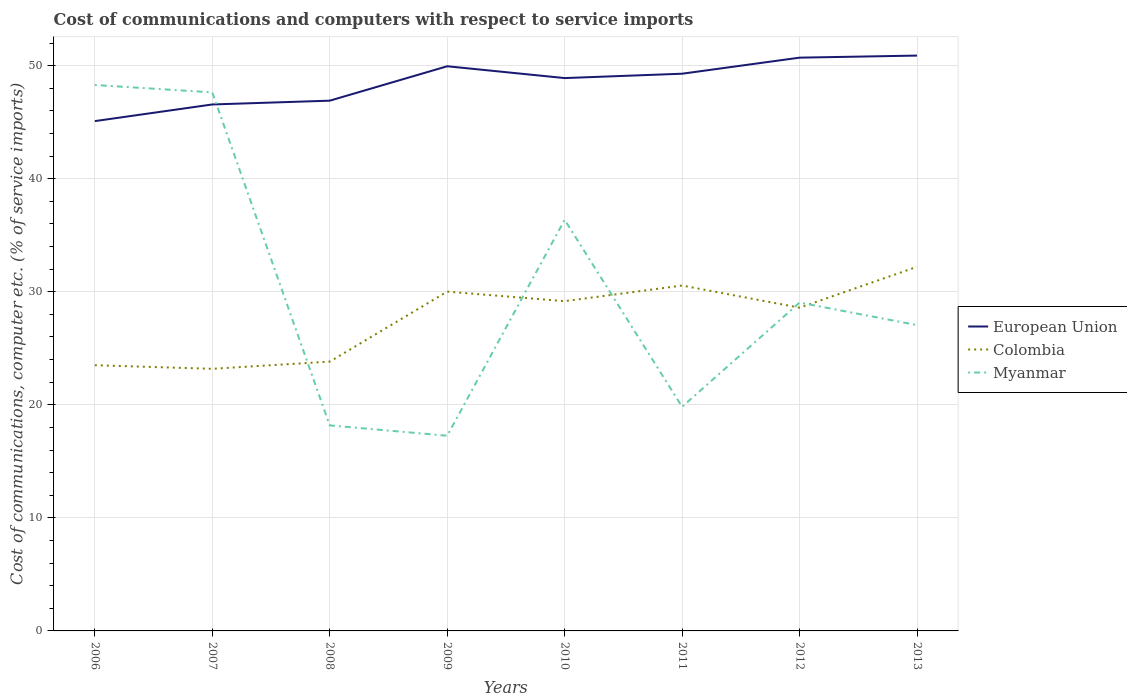How many different coloured lines are there?
Provide a succinct answer. 3. Does the line corresponding to European Union intersect with the line corresponding to Colombia?
Provide a succinct answer. No. Across all years, what is the maximum cost of communications and computers in European Union?
Your answer should be very brief. 45.09. What is the total cost of communications and computers in Colombia in the graph?
Provide a short and direct response. -5.09. What is the difference between the highest and the second highest cost of communications and computers in Colombia?
Offer a terse response. 9.02. What is the difference between the highest and the lowest cost of communications and computers in Colombia?
Keep it short and to the point. 5. Are the values on the major ticks of Y-axis written in scientific E-notation?
Your response must be concise. No. Does the graph contain grids?
Ensure brevity in your answer.  Yes. Where does the legend appear in the graph?
Provide a succinct answer. Center right. How are the legend labels stacked?
Provide a succinct answer. Vertical. What is the title of the graph?
Offer a very short reply. Cost of communications and computers with respect to service imports. What is the label or title of the Y-axis?
Make the answer very short. Cost of communications, computer etc. (% of service imports). What is the Cost of communications, computer etc. (% of service imports) of European Union in 2006?
Your answer should be very brief. 45.09. What is the Cost of communications, computer etc. (% of service imports) in Colombia in 2006?
Your answer should be compact. 23.5. What is the Cost of communications, computer etc. (% of service imports) in Myanmar in 2006?
Your answer should be very brief. 48.29. What is the Cost of communications, computer etc. (% of service imports) of European Union in 2007?
Your answer should be very brief. 46.57. What is the Cost of communications, computer etc. (% of service imports) of Colombia in 2007?
Provide a succinct answer. 23.18. What is the Cost of communications, computer etc. (% of service imports) in Myanmar in 2007?
Your response must be concise. 47.64. What is the Cost of communications, computer etc. (% of service imports) in European Union in 2008?
Your answer should be very brief. 46.9. What is the Cost of communications, computer etc. (% of service imports) of Colombia in 2008?
Your response must be concise. 23.82. What is the Cost of communications, computer etc. (% of service imports) of Myanmar in 2008?
Provide a succinct answer. 18.18. What is the Cost of communications, computer etc. (% of service imports) in European Union in 2009?
Your response must be concise. 49.95. What is the Cost of communications, computer etc. (% of service imports) in Colombia in 2009?
Your answer should be very brief. 30.01. What is the Cost of communications, computer etc. (% of service imports) of Myanmar in 2009?
Make the answer very short. 17.26. What is the Cost of communications, computer etc. (% of service imports) of European Union in 2010?
Offer a terse response. 48.9. What is the Cost of communications, computer etc. (% of service imports) of Colombia in 2010?
Keep it short and to the point. 29.17. What is the Cost of communications, computer etc. (% of service imports) in Myanmar in 2010?
Offer a very short reply. 36.37. What is the Cost of communications, computer etc. (% of service imports) in European Union in 2011?
Keep it short and to the point. 49.29. What is the Cost of communications, computer etc. (% of service imports) of Colombia in 2011?
Provide a short and direct response. 30.55. What is the Cost of communications, computer etc. (% of service imports) in Myanmar in 2011?
Make the answer very short. 19.82. What is the Cost of communications, computer etc. (% of service imports) in European Union in 2012?
Your answer should be compact. 50.71. What is the Cost of communications, computer etc. (% of service imports) of Colombia in 2012?
Offer a very short reply. 28.59. What is the Cost of communications, computer etc. (% of service imports) in Myanmar in 2012?
Give a very brief answer. 29.04. What is the Cost of communications, computer etc. (% of service imports) of European Union in 2013?
Your answer should be very brief. 50.89. What is the Cost of communications, computer etc. (% of service imports) in Colombia in 2013?
Provide a short and direct response. 32.21. What is the Cost of communications, computer etc. (% of service imports) of Myanmar in 2013?
Your answer should be compact. 27.05. Across all years, what is the maximum Cost of communications, computer etc. (% of service imports) in European Union?
Your response must be concise. 50.89. Across all years, what is the maximum Cost of communications, computer etc. (% of service imports) of Colombia?
Your response must be concise. 32.21. Across all years, what is the maximum Cost of communications, computer etc. (% of service imports) in Myanmar?
Keep it short and to the point. 48.29. Across all years, what is the minimum Cost of communications, computer etc. (% of service imports) in European Union?
Your response must be concise. 45.09. Across all years, what is the minimum Cost of communications, computer etc. (% of service imports) of Colombia?
Ensure brevity in your answer.  23.18. Across all years, what is the minimum Cost of communications, computer etc. (% of service imports) in Myanmar?
Your answer should be compact. 17.26. What is the total Cost of communications, computer etc. (% of service imports) of European Union in the graph?
Give a very brief answer. 388.29. What is the total Cost of communications, computer etc. (% of service imports) of Colombia in the graph?
Provide a short and direct response. 221.03. What is the total Cost of communications, computer etc. (% of service imports) of Myanmar in the graph?
Your answer should be very brief. 243.65. What is the difference between the Cost of communications, computer etc. (% of service imports) of European Union in 2006 and that in 2007?
Offer a terse response. -1.47. What is the difference between the Cost of communications, computer etc. (% of service imports) in Colombia in 2006 and that in 2007?
Offer a terse response. 0.32. What is the difference between the Cost of communications, computer etc. (% of service imports) in Myanmar in 2006 and that in 2007?
Ensure brevity in your answer.  0.65. What is the difference between the Cost of communications, computer etc. (% of service imports) of European Union in 2006 and that in 2008?
Give a very brief answer. -1.81. What is the difference between the Cost of communications, computer etc. (% of service imports) of Colombia in 2006 and that in 2008?
Offer a terse response. -0.32. What is the difference between the Cost of communications, computer etc. (% of service imports) of Myanmar in 2006 and that in 2008?
Make the answer very short. 30.11. What is the difference between the Cost of communications, computer etc. (% of service imports) in European Union in 2006 and that in 2009?
Ensure brevity in your answer.  -4.85. What is the difference between the Cost of communications, computer etc. (% of service imports) in Colombia in 2006 and that in 2009?
Make the answer very short. -6.51. What is the difference between the Cost of communications, computer etc. (% of service imports) of Myanmar in 2006 and that in 2009?
Keep it short and to the point. 31.02. What is the difference between the Cost of communications, computer etc. (% of service imports) of European Union in 2006 and that in 2010?
Make the answer very short. -3.81. What is the difference between the Cost of communications, computer etc. (% of service imports) in Colombia in 2006 and that in 2010?
Make the answer very short. -5.67. What is the difference between the Cost of communications, computer etc. (% of service imports) of Myanmar in 2006 and that in 2010?
Give a very brief answer. 11.92. What is the difference between the Cost of communications, computer etc. (% of service imports) of European Union in 2006 and that in 2011?
Give a very brief answer. -4.19. What is the difference between the Cost of communications, computer etc. (% of service imports) of Colombia in 2006 and that in 2011?
Offer a very short reply. -7.05. What is the difference between the Cost of communications, computer etc. (% of service imports) of Myanmar in 2006 and that in 2011?
Your answer should be very brief. 28.46. What is the difference between the Cost of communications, computer etc. (% of service imports) of European Union in 2006 and that in 2012?
Offer a terse response. -5.61. What is the difference between the Cost of communications, computer etc. (% of service imports) in Colombia in 2006 and that in 2012?
Your answer should be compact. -5.09. What is the difference between the Cost of communications, computer etc. (% of service imports) in Myanmar in 2006 and that in 2012?
Offer a terse response. 19.24. What is the difference between the Cost of communications, computer etc. (% of service imports) in European Union in 2006 and that in 2013?
Offer a very short reply. -5.8. What is the difference between the Cost of communications, computer etc. (% of service imports) of Colombia in 2006 and that in 2013?
Ensure brevity in your answer.  -8.71. What is the difference between the Cost of communications, computer etc. (% of service imports) of Myanmar in 2006 and that in 2013?
Your answer should be compact. 21.24. What is the difference between the Cost of communications, computer etc. (% of service imports) of European Union in 2007 and that in 2008?
Your answer should be compact. -0.33. What is the difference between the Cost of communications, computer etc. (% of service imports) in Colombia in 2007 and that in 2008?
Your answer should be very brief. -0.64. What is the difference between the Cost of communications, computer etc. (% of service imports) in Myanmar in 2007 and that in 2008?
Offer a terse response. 29.46. What is the difference between the Cost of communications, computer etc. (% of service imports) in European Union in 2007 and that in 2009?
Your answer should be compact. -3.38. What is the difference between the Cost of communications, computer etc. (% of service imports) of Colombia in 2007 and that in 2009?
Provide a short and direct response. -6.83. What is the difference between the Cost of communications, computer etc. (% of service imports) of Myanmar in 2007 and that in 2009?
Keep it short and to the point. 30.37. What is the difference between the Cost of communications, computer etc. (% of service imports) of European Union in 2007 and that in 2010?
Provide a succinct answer. -2.33. What is the difference between the Cost of communications, computer etc. (% of service imports) of Colombia in 2007 and that in 2010?
Offer a very short reply. -5.98. What is the difference between the Cost of communications, computer etc. (% of service imports) in Myanmar in 2007 and that in 2010?
Your response must be concise. 11.27. What is the difference between the Cost of communications, computer etc. (% of service imports) of European Union in 2007 and that in 2011?
Offer a terse response. -2.72. What is the difference between the Cost of communications, computer etc. (% of service imports) of Colombia in 2007 and that in 2011?
Make the answer very short. -7.37. What is the difference between the Cost of communications, computer etc. (% of service imports) of Myanmar in 2007 and that in 2011?
Offer a terse response. 27.81. What is the difference between the Cost of communications, computer etc. (% of service imports) of European Union in 2007 and that in 2012?
Ensure brevity in your answer.  -4.14. What is the difference between the Cost of communications, computer etc. (% of service imports) in Colombia in 2007 and that in 2012?
Offer a very short reply. -5.41. What is the difference between the Cost of communications, computer etc. (% of service imports) of Myanmar in 2007 and that in 2012?
Your answer should be compact. 18.59. What is the difference between the Cost of communications, computer etc. (% of service imports) of European Union in 2007 and that in 2013?
Give a very brief answer. -4.32. What is the difference between the Cost of communications, computer etc. (% of service imports) in Colombia in 2007 and that in 2013?
Provide a short and direct response. -9.02. What is the difference between the Cost of communications, computer etc. (% of service imports) of Myanmar in 2007 and that in 2013?
Provide a succinct answer. 20.59. What is the difference between the Cost of communications, computer etc. (% of service imports) in European Union in 2008 and that in 2009?
Provide a short and direct response. -3.04. What is the difference between the Cost of communications, computer etc. (% of service imports) in Colombia in 2008 and that in 2009?
Your answer should be compact. -6.19. What is the difference between the Cost of communications, computer etc. (% of service imports) in Myanmar in 2008 and that in 2009?
Provide a short and direct response. 0.92. What is the difference between the Cost of communications, computer etc. (% of service imports) of European Union in 2008 and that in 2010?
Make the answer very short. -2. What is the difference between the Cost of communications, computer etc. (% of service imports) in Colombia in 2008 and that in 2010?
Your answer should be compact. -5.35. What is the difference between the Cost of communications, computer etc. (% of service imports) in Myanmar in 2008 and that in 2010?
Offer a very short reply. -18.19. What is the difference between the Cost of communications, computer etc. (% of service imports) of European Union in 2008 and that in 2011?
Your answer should be compact. -2.39. What is the difference between the Cost of communications, computer etc. (% of service imports) in Colombia in 2008 and that in 2011?
Make the answer very short. -6.73. What is the difference between the Cost of communications, computer etc. (% of service imports) of Myanmar in 2008 and that in 2011?
Offer a terse response. -1.65. What is the difference between the Cost of communications, computer etc. (% of service imports) in European Union in 2008 and that in 2012?
Make the answer very short. -3.81. What is the difference between the Cost of communications, computer etc. (% of service imports) in Colombia in 2008 and that in 2012?
Offer a terse response. -4.77. What is the difference between the Cost of communications, computer etc. (% of service imports) of Myanmar in 2008 and that in 2012?
Keep it short and to the point. -10.86. What is the difference between the Cost of communications, computer etc. (% of service imports) in European Union in 2008 and that in 2013?
Offer a very short reply. -3.99. What is the difference between the Cost of communications, computer etc. (% of service imports) of Colombia in 2008 and that in 2013?
Your answer should be compact. -8.38. What is the difference between the Cost of communications, computer etc. (% of service imports) of Myanmar in 2008 and that in 2013?
Make the answer very short. -8.87. What is the difference between the Cost of communications, computer etc. (% of service imports) in European Union in 2009 and that in 2010?
Offer a very short reply. 1.05. What is the difference between the Cost of communications, computer etc. (% of service imports) in Colombia in 2009 and that in 2010?
Provide a succinct answer. 0.84. What is the difference between the Cost of communications, computer etc. (% of service imports) of Myanmar in 2009 and that in 2010?
Give a very brief answer. -19.1. What is the difference between the Cost of communications, computer etc. (% of service imports) in European Union in 2009 and that in 2011?
Make the answer very short. 0.66. What is the difference between the Cost of communications, computer etc. (% of service imports) of Colombia in 2009 and that in 2011?
Your answer should be compact. -0.54. What is the difference between the Cost of communications, computer etc. (% of service imports) of Myanmar in 2009 and that in 2011?
Keep it short and to the point. -2.56. What is the difference between the Cost of communications, computer etc. (% of service imports) in European Union in 2009 and that in 2012?
Your response must be concise. -0.76. What is the difference between the Cost of communications, computer etc. (% of service imports) of Colombia in 2009 and that in 2012?
Your response must be concise. 1.42. What is the difference between the Cost of communications, computer etc. (% of service imports) of Myanmar in 2009 and that in 2012?
Ensure brevity in your answer.  -11.78. What is the difference between the Cost of communications, computer etc. (% of service imports) of European Union in 2009 and that in 2013?
Provide a succinct answer. -0.94. What is the difference between the Cost of communications, computer etc. (% of service imports) in Colombia in 2009 and that in 2013?
Give a very brief answer. -2.19. What is the difference between the Cost of communications, computer etc. (% of service imports) in Myanmar in 2009 and that in 2013?
Your answer should be compact. -9.79. What is the difference between the Cost of communications, computer etc. (% of service imports) in European Union in 2010 and that in 2011?
Offer a terse response. -0.39. What is the difference between the Cost of communications, computer etc. (% of service imports) in Colombia in 2010 and that in 2011?
Provide a short and direct response. -1.38. What is the difference between the Cost of communications, computer etc. (% of service imports) of Myanmar in 2010 and that in 2011?
Offer a terse response. 16.54. What is the difference between the Cost of communications, computer etc. (% of service imports) in European Union in 2010 and that in 2012?
Ensure brevity in your answer.  -1.81. What is the difference between the Cost of communications, computer etc. (% of service imports) in Colombia in 2010 and that in 2012?
Your answer should be very brief. 0.58. What is the difference between the Cost of communications, computer etc. (% of service imports) in Myanmar in 2010 and that in 2012?
Your answer should be very brief. 7.32. What is the difference between the Cost of communications, computer etc. (% of service imports) in European Union in 2010 and that in 2013?
Your response must be concise. -1.99. What is the difference between the Cost of communications, computer etc. (% of service imports) in Colombia in 2010 and that in 2013?
Offer a terse response. -3.04. What is the difference between the Cost of communications, computer etc. (% of service imports) in Myanmar in 2010 and that in 2013?
Provide a short and direct response. 9.32. What is the difference between the Cost of communications, computer etc. (% of service imports) of European Union in 2011 and that in 2012?
Offer a terse response. -1.42. What is the difference between the Cost of communications, computer etc. (% of service imports) of Colombia in 2011 and that in 2012?
Make the answer very short. 1.96. What is the difference between the Cost of communications, computer etc. (% of service imports) in Myanmar in 2011 and that in 2012?
Your response must be concise. -9.22. What is the difference between the Cost of communications, computer etc. (% of service imports) in European Union in 2011 and that in 2013?
Provide a succinct answer. -1.6. What is the difference between the Cost of communications, computer etc. (% of service imports) in Colombia in 2011 and that in 2013?
Keep it short and to the point. -1.65. What is the difference between the Cost of communications, computer etc. (% of service imports) in Myanmar in 2011 and that in 2013?
Your answer should be compact. -7.22. What is the difference between the Cost of communications, computer etc. (% of service imports) in European Union in 2012 and that in 2013?
Offer a terse response. -0.18. What is the difference between the Cost of communications, computer etc. (% of service imports) in Colombia in 2012 and that in 2013?
Ensure brevity in your answer.  -3.62. What is the difference between the Cost of communications, computer etc. (% of service imports) in Myanmar in 2012 and that in 2013?
Make the answer very short. 1.99. What is the difference between the Cost of communications, computer etc. (% of service imports) of European Union in 2006 and the Cost of communications, computer etc. (% of service imports) of Colombia in 2007?
Provide a succinct answer. 21.91. What is the difference between the Cost of communications, computer etc. (% of service imports) of European Union in 2006 and the Cost of communications, computer etc. (% of service imports) of Myanmar in 2007?
Provide a short and direct response. -2.54. What is the difference between the Cost of communications, computer etc. (% of service imports) of Colombia in 2006 and the Cost of communications, computer etc. (% of service imports) of Myanmar in 2007?
Keep it short and to the point. -24.14. What is the difference between the Cost of communications, computer etc. (% of service imports) of European Union in 2006 and the Cost of communications, computer etc. (% of service imports) of Colombia in 2008?
Provide a short and direct response. 21.27. What is the difference between the Cost of communications, computer etc. (% of service imports) in European Union in 2006 and the Cost of communications, computer etc. (% of service imports) in Myanmar in 2008?
Your answer should be compact. 26.92. What is the difference between the Cost of communications, computer etc. (% of service imports) in Colombia in 2006 and the Cost of communications, computer etc. (% of service imports) in Myanmar in 2008?
Your answer should be very brief. 5.32. What is the difference between the Cost of communications, computer etc. (% of service imports) of European Union in 2006 and the Cost of communications, computer etc. (% of service imports) of Colombia in 2009?
Your answer should be compact. 15.08. What is the difference between the Cost of communications, computer etc. (% of service imports) in European Union in 2006 and the Cost of communications, computer etc. (% of service imports) in Myanmar in 2009?
Keep it short and to the point. 27.83. What is the difference between the Cost of communications, computer etc. (% of service imports) in Colombia in 2006 and the Cost of communications, computer etc. (% of service imports) in Myanmar in 2009?
Your answer should be very brief. 6.24. What is the difference between the Cost of communications, computer etc. (% of service imports) in European Union in 2006 and the Cost of communications, computer etc. (% of service imports) in Colombia in 2010?
Provide a short and direct response. 15.93. What is the difference between the Cost of communications, computer etc. (% of service imports) of European Union in 2006 and the Cost of communications, computer etc. (% of service imports) of Myanmar in 2010?
Give a very brief answer. 8.73. What is the difference between the Cost of communications, computer etc. (% of service imports) in Colombia in 2006 and the Cost of communications, computer etc. (% of service imports) in Myanmar in 2010?
Your answer should be compact. -12.87. What is the difference between the Cost of communications, computer etc. (% of service imports) of European Union in 2006 and the Cost of communications, computer etc. (% of service imports) of Colombia in 2011?
Provide a short and direct response. 14.54. What is the difference between the Cost of communications, computer etc. (% of service imports) in European Union in 2006 and the Cost of communications, computer etc. (% of service imports) in Myanmar in 2011?
Provide a short and direct response. 25.27. What is the difference between the Cost of communications, computer etc. (% of service imports) in Colombia in 2006 and the Cost of communications, computer etc. (% of service imports) in Myanmar in 2011?
Your answer should be compact. 3.68. What is the difference between the Cost of communications, computer etc. (% of service imports) in European Union in 2006 and the Cost of communications, computer etc. (% of service imports) in Colombia in 2012?
Your answer should be compact. 16.5. What is the difference between the Cost of communications, computer etc. (% of service imports) in European Union in 2006 and the Cost of communications, computer etc. (% of service imports) in Myanmar in 2012?
Your answer should be very brief. 16.05. What is the difference between the Cost of communications, computer etc. (% of service imports) of Colombia in 2006 and the Cost of communications, computer etc. (% of service imports) of Myanmar in 2012?
Offer a terse response. -5.54. What is the difference between the Cost of communications, computer etc. (% of service imports) of European Union in 2006 and the Cost of communications, computer etc. (% of service imports) of Colombia in 2013?
Your response must be concise. 12.89. What is the difference between the Cost of communications, computer etc. (% of service imports) in European Union in 2006 and the Cost of communications, computer etc. (% of service imports) in Myanmar in 2013?
Ensure brevity in your answer.  18.04. What is the difference between the Cost of communications, computer etc. (% of service imports) in Colombia in 2006 and the Cost of communications, computer etc. (% of service imports) in Myanmar in 2013?
Offer a very short reply. -3.55. What is the difference between the Cost of communications, computer etc. (% of service imports) in European Union in 2007 and the Cost of communications, computer etc. (% of service imports) in Colombia in 2008?
Make the answer very short. 22.75. What is the difference between the Cost of communications, computer etc. (% of service imports) of European Union in 2007 and the Cost of communications, computer etc. (% of service imports) of Myanmar in 2008?
Give a very brief answer. 28.39. What is the difference between the Cost of communications, computer etc. (% of service imports) of Colombia in 2007 and the Cost of communications, computer etc. (% of service imports) of Myanmar in 2008?
Provide a short and direct response. 5.01. What is the difference between the Cost of communications, computer etc. (% of service imports) of European Union in 2007 and the Cost of communications, computer etc. (% of service imports) of Colombia in 2009?
Give a very brief answer. 16.55. What is the difference between the Cost of communications, computer etc. (% of service imports) in European Union in 2007 and the Cost of communications, computer etc. (% of service imports) in Myanmar in 2009?
Provide a short and direct response. 29.3. What is the difference between the Cost of communications, computer etc. (% of service imports) of Colombia in 2007 and the Cost of communications, computer etc. (% of service imports) of Myanmar in 2009?
Make the answer very short. 5.92. What is the difference between the Cost of communications, computer etc. (% of service imports) in European Union in 2007 and the Cost of communications, computer etc. (% of service imports) in Colombia in 2010?
Provide a short and direct response. 17.4. What is the difference between the Cost of communications, computer etc. (% of service imports) in European Union in 2007 and the Cost of communications, computer etc. (% of service imports) in Myanmar in 2010?
Your response must be concise. 10.2. What is the difference between the Cost of communications, computer etc. (% of service imports) in Colombia in 2007 and the Cost of communications, computer etc. (% of service imports) in Myanmar in 2010?
Your answer should be very brief. -13.18. What is the difference between the Cost of communications, computer etc. (% of service imports) in European Union in 2007 and the Cost of communications, computer etc. (% of service imports) in Colombia in 2011?
Offer a terse response. 16.01. What is the difference between the Cost of communications, computer etc. (% of service imports) in European Union in 2007 and the Cost of communications, computer etc. (% of service imports) in Myanmar in 2011?
Give a very brief answer. 26.74. What is the difference between the Cost of communications, computer etc. (% of service imports) in Colombia in 2007 and the Cost of communications, computer etc. (% of service imports) in Myanmar in 2011?
Provide a succinct answer. 3.36. What is the difference between the Cost of communications, computer etc. (% of service imports) of European Union in 2007 and the Cost of communications, computer etc. (% of service imports) of Colombia in 2012?
Provide a succinct answer. 17.98. What is the difference between the Cost of communications, computer etc. (% of service imports) in European Union in 2007 and the Cost of communications, computer etc. (% of service imports) in Myanmar in 2012?
Keep it short and to the point. 17.52. What is the difference between the Cost of communications, computer etc. (% of service imports) in Colombia in 2007 and the Cost of communications, computer etc. (% of service imports) in Myanmar in 2012?
Give a very brief answer. -5.86. What is the difference between the Cost of communications, computer etc. (% of service imports) of European Union in 2007 and the Cost of communications, computer etc. (% of service imports) of Colombia in 2013?
Your answer should be compact. 14.36. What is the difference between the Cost of communications, computer etc. (% of service imports) of European Union in 2007 and the Cost of communications, computer etc. (% of service imports) of Myanmar in 2013?
Your answer should be compact. 19.52. What is the difference between the Cost of communications, computer etc. (% of service imports) of Colombia in 2007 and the Cost of communications, computer etc. (% of service imports) of Myanmar in 2013?
Your answer should be very brief. -3.87. What is the difference between the Cost of communications, computer etc. (% of service imports) of European Union in 2008 and the Cost of communications, computer etc. (% of service imports) of Colombia in 2009?
Provide a short and direct response. 16.89. What is the difference between the Cost of communications, computer etc. (% of service imports) in European Union in 2008 and the Cost of communications, computer etc. (% of service imports) in Myanmar in 2009?
Keep it short and to the point. 29.64. What is the difference between the Cost of communications, computer etc. (% of service imports) in Colombia in 2008 and the Cost of communications, computer etc. (% of service imports) in Myanmar in 2009?
Ensure brevity in your answer.  6.56. What is the difference between the Cost of communications, computer etc. (% of service imports) of European Union in 2008 and the Cost of communications, computer etc. (% of service imports) of Colombia in 2010?
Offer a very short reply. 17.73. What is the difference between the Cost of communications, computer etc. (% of service imports) in European Union in 2008 and the Cost of communications, computer etc. (% of service imports) in Myanmar in 2010?
Provide a succinct answer. 10.54. What is the difference between the Cost of communications, computer etc. (% of service imports) of Colombia in 2008 and the Cost of communications, computer etc. (% of service imports) of Myanmar in 2010?
Offer a very short reply. -12.54. What is the difference between the Cost of communications, computer etc. (% of service imports) in European Union in 2008 and the Cost of communications, computer etc. (% of service imports) in Colombia in 2011?
Keep it short and to the point. 16.35. What is the difference between the Cost of communications, computer etc. (% of service imports) in European Union in 2008 and the Cost of communications, computer etc. (% of service imports) in Myanmar in 2011?
Ensure brevity in your answer.  27.08. What is the difference between the Cost of communications, computer etc. (% of service imports) of Colombia in 2008 and the Cost of communications, computer etc. (% of service imports) of Myanmar in 2011?
Offer a terse response. 4. What is the difference between the Cost of communications, computer etc. (% of service imports) in European Union in 2008 and the Cost of communications, computer etc. (% of service imports) in Colombia in 2012?
Give a very brief answer. 18.31. What is the difference between the Cost of communications, computer etc. (% of service imports) in European Union in 2008 and the Cost of communications, computer etc. (% of service imports) in Myanmar in 2012?
Keep it short and to the point. 17.86. What is the difference between the Cost of communications, computer etc. (% of service imports) of Colombia in 2008 and the Cost of communications, computer etc. (% of service imports) of Myanmar in 2012?
Your answer should be compact. -5.22. What is the difference between the Cost of communications, computer etc. (% of service imports) of European Union in 2008 and the Cost of communications, computer etc. (% of service imports) of Colombia in 2013?
Provide a succinct answer. 14.7. What is the difference between the Cost of communications, computer etc. (% of service imports) of European Union in 2008 and the Cost of communications, computer etc. (% of service imports) of Myanmar in 2013?
Your answer should be compact. 19.85. What is the difference between the Cost of communications, computer etc. (% of service imports) of Colombia in 2008 and the Cost of communications, computer etc. (% of service imports) of Myanmar in 2013?
Give a very brief answer. -3.23. What is the difference between the Cost of communications, computer etc. (% of service imports) in European Union in 2009 and the Cost of communications, computer etc. (% of service imports) in Colombia in 2010?
Your answer should be compact. 20.78. What is the difference between the Cost of communications, computer etc. (% of service imports) of European Union in 2009 and the Cost of communications, computer etc. (% of service imports) of Myanmar in 2010?
Your response must be concise. 13.58. What is the difference between the Cost of communications, computer etc. (% of service imports) of Colombia in 2009 and the Cost of communications, computer etc. (% of service imports) of Myanmar in 2010?
Your answer should be compact. -6.35. What is the difference between the Cost of communications, computer etc. (% of service imports) of European Union in 2009 and the Cost of communications, computer etc. (% of service imports) of Colombia in 2011?
Give a very brief answer. 19.39. What is the difference between the Cost of communications, computer etc. (% of service imports) in European Union in 2009 and the Cost of communications, computer etc. (% of service imports) in Myanmar in 2011?
Your answer should be very brief. 30.12. What is the difference between the Cost of communications, computer etc. (% of service imports) of Colombia in 2009 and the Cost of communications, computer etc. (% of service imports) of Myanmar in 2011?
Your response must be concise. 10.19. What is the difference between the Cost of communications, computer etc. (% of service imports) of European Union in 2009 and the Cost of communications, computer etc. (% of service imports) of Colombia in 2012?
Offer a terse response. 21.36. What is the difference between the Cost of communications, computer etc. (% of service imports) in European Union in 2009 and the Cost of communications, computer etc. (% of service imports) in Myanmar in 2012?
Offer a very short reply. 20.9. What is the difference between the Cost of communications, computer etc. (% of service imports) in Colombia in 2009 and the Cost of communications, computer etc. (% of service imports) in Myanmar in 2012?
Keep it short and to the point. 0.97. What is the difference between the Cost of communications, computer etc. (% of service imports) in European Union in 2009 and the Cost of communications, computer etc. (% of service imports) in Colombia in 2013?
Keep it short and to the point. 17.74. What is the difference between the Cost of communications, computer etc. (% of service imports) in European Union in 2009 and the Cost of communications, computer etc. (% of service imports) in Myanmar in 2013?
Give a very brief answer. 22.9. What is the difference between the Cost of communications, computer etc. (% of service imports) of Colombia in 2009 and the Cost of communications, computer etc. (% of service imports) of Myanmar in 2013?
Your answer should be very brief. 2.96. What is the difference between the Cost of communications, computer etc. (% of service imports) of European Union in 2010 and the Cost of communications, computer etc. (% of service imports) of Colombia in 2011?
Keep it short and to the point. 18.35. What is the difference between the Cost of communications, computer etc. (% of service imports) in European Union in 2010 and the Cost of communications, computer etc. (% of service imports) in Myanmar in 2011?
Your answer should be very brief. 29.07. What is the difference between the Cost of communications, computer etc. (% of service imports) in Colombia in 2010 and the Cost of communications, computer etc. (% of service imports) in Myanmar in 2011?
Offer a terse response. 9.34. What is the difference between the Cost of communications, computer etc. (% of service imports) of European Union in 2010 and the Cost of communications, computer etc. (% of service imports) of Colombia in 2012?
Your response must be concise. 20.31. What is the difference between the Cost of communications, computer etc. (% of service imports) of European Union in 2010 and the Cost of communications, computer etc. (% of service imports) of Myanmar in 2012?
Provide a short and direct response. 19.86. What is the difference between the Cost of communications, computer etc. (% of service imports) of Colombia in 2010 and the Cost of communications, computer etc. (% of service imports) of Myanmar in 2012?
Keep it short and to the point. 0.12. What is the difference between the Cost of communications, computer etc. (% of service imports) of European Union in 2010 and the Cost of communications, computer etc. (% of service imports) of Colombia in 2013?
Offer a terse response. 16.69. What is the difference between the Cost of communications, computer etc. (% of service imports) of European Union in 2010 and the Cost of communications, computer etc. (% of service imports) of Myanmar in 2013?
Keep it short and to the point. 21.85. What is the difference between the Cost of communications, computer etc. (% of service imports) of Colombia in 2010 and the Cost of communications, computer etc. (% of service imports) of Myanmar in 2013?
Give a very brief answer. 2.12. What is the difference between the Cost of communications, computer etc. (% of service imports) in European Union in 2011 and the Cost of communications, computer etc. (% of service imports) in Colombia in 2012?
Offer a terse response. 20.7. What is the difference between the Cost of communications, computer etc. (% of service imports) in European Union in 2011 and the Cost of communications, computer etc. (% of service imports) in Myanmar in 2012?
Ensure brevity in your answer.  20.24. What is the difference between the Cost of communications, computer etc. (% of service imports) in Colombia in 2011 and the Cost of communications, computer etc. (% of service imports) in Myanmar in 2012?
Ensure brevity in your answer.  1.51. What is the difference between the Cost of communications, computer etc. (% of service imports) in European Union in 2011 and the Cost of communications, computer etc. (% of service imports) in Colombia in 2013?
Make the answer very short. 17.08. What is the difference between the Cost of communications, computer etc. (% of service imports) in European Union in 2011 and the Cost of communications, computer etc. (% of service imports) in Myanmar in 2013?
Your response must be concise. 22.24. What is the difference between the Cost of communications, computer etc. (% of service imports) of Colombia in 2011 and the Cost of communications, computer etc. (% of service imports) of Myanmar in 2013?
Provide a short and direct response. 3.5. What is the difference between the Cost of communications, computer etc. (% of service imports) of European Union in 2012 and the Cost of communications, computer etc. (% of service imports) of Colombia in 2013?
Provide a succinct answer. 18.5. What is the difference between the Cost of communications, computer etc. (% of service imports) of European Union in 2012 and the Cost of communications, computer etc. (% of service imports) of Myanmar in 2013?
Your answer should be very brief. 23.66. What is the difference between the Cost of communications, computer etc. (% of service imports) in Colombia in 2012 and the Cost of communications, computer etc. (% of service imports) in Myanmar in 2013?
Make the answer very short. 1.54. What is the average Cost of communications, computer etc. (% of service imports) of European Union per year?
Provide a short and direct response. 48.54. What is the average Cost of communications, computer etc. (% of service imports) in Colombia per year?
Ensure brevity in your answer.  27.63. What is the average Cost of communications, computer etc. (% of service imports) of Myanmar per year?
Provide a short and direct response. 30.46. In the year 2006, what is the difference between the Cost of communications, computer etc. (% of service imports) in European Union and Cost of communications, computer etc. (% of service imports) in Colombia?
Your answer should be very brief. 21.59. In the year 2006, what is the difference between the Cost of communications, computer etc. (% of service imports) of European Union and Cost of communications, computer etc. (% of service imports) of Myanmar?
Offer a terse response. -3.19. In the year 2006, what is the difference between the Cost of communications, computer etc. (% of service imports) of Colombia and Cost of communications, computer etc. (% of service imports) of Myanmar?
Ensure brevity in your answer.  -24.79. In the year 2007, what is the difference between the Cost of communications, computer etc. (% of service imports) in European Union and Cost of communications, computer etc. (% of service imports) in Colombia?
Your answer should be compact. 23.38. In the year 2007, what is the difference between the Cost of communications, computer etc. (% of service imports) in European Union and Cost of communications, computer etc. (% of service imports) in Myanmar?
Your answer should be very brief. -1.07. In the year 2007, what is the difference between the Cost of communications, computer etc. (% of service imports) in Colombia and Cost of communications, computer etc. (% of service imports) in Myanmar?
Your response must be concise. -24.45. In the year 2008, what is the difference between the Cost of communications, computer etc. (% of service imports) of European Union and Cost of communications, computer etc. (% of service imports) of Colombia?
Keep it short and to the point. 23.08. In the year 2008, what is the difference between the Cost of communications, computer etc. (% of service imports) of European Union and Cost of communications, computer etc. (% of service imports) of Myanmar?
Provide a succinct answer. 28.72. In the year 2008, what is the difference between the Cost of communications, computer etc. (% of service imports) in Colombia and Cost of communications, computer etc. (% of service imports) in Myanmar?
Provide a succinct answer. 5.64. In the year 2009, what is the difference between the Cost of communications, computer etc. (% of service imports) in European Union and Cost of communications, computer etc. (% of service imports) in Colombia?
Give a very brief answer. 19.93. In the year 2009, what is the difference between the Cost of communications, computer etc. (% of service imports) in European Union and Cost of communications, computer etc. (% of service imports) in Myanmar?
Keep it short and to the point. 32.68. In the year 2009, what is the difference between the Cost of communications, computer etc. (% of service imports) of Colombia and Cost of communications, computer etc. (% of service imports) of Myanmar?
Give a very brief answer. 12.75. In the year 2010, what is the difference between the Cost of communications, computer etc. (% of service imports) in European Union and Cost of communications, computer etc. (% of service imports) in Colombia?
Provide a short and direct response. 19.73. In the year 2010, what is the difference between the Cost of communications, computer etc. (% of service imports) in European Union and Cost of communications, computer etc. (% of service imports) in Myanmar?
Make the answer very short. 12.53. In the year 2010, what is the difference between the Cost of communications, computer etc. (% of service imports) of Colombia and Cost of communications, computer etc. (% of service imports) of Myanmar?
Ensure brevity in your answer.  -7.2. In the year 2011, what is the difference between the Cost of communications, computer etc. (% of service imports) in European Union and Cost of communications, computer etc. (% of service imports) in Colombia?
Ensure brevity in your answer.  18.74. In the year 2011, what is the difference between the Cost of communications, computer etc. (% of service imports) in European Union and Cost of communications, computer etc. (% of service imports) in Myanmar?
Offer a very short reply. 29.46. In the year 2011, what is the difference between the Cost of communications, computer etc. (% of service imports) in Colombia and Cost of communications, computer etc. (% of service imports) in Myanmar?
Your answer should be very brief. 10.73. In the year 2012, what is the difference between the Cost of communications, computer etc. (% of service imports) of European Union and Cost of communications, computer etc. (% of service imports) of Colombia?
Ensure brevity in your answer.  22.12. In the year 2012, what is the difference between the Cost of communications, computer etc. (% of service imports) of European Union and Cost of communications, computer etc. (% of service imports) of Myanmar?
Make the answer very short. 21.66. In the year 2012, what is the difference between the Cost of communications, computer etc. (% of service imports) of Colombia and Cost of communications, computer etc. (% of service imports) of Myanmar?
Give a very brief answer. -0.45. In the year 2013, what is the difference between the Cost of communications, computer etc. (% of service imports) in European Union and Cost of communications, computer etc. (% of service imports) in Colombia?
Keep it short and to the point. 18.68. In the year 2013, what is the difference between the Cost of communications, computer etc. (% of service imports) in European Union and Cost of communications, computer etc. (% of service imports) in Myanmar?
Offer a very short reply. 23.84. In the year 2013, what is the difference between the Cost of communications, computer etc. (% of service imports) in Colombia and Cost of communications, computer etc. (% of service imports) in Myanmar?
Give a very brief answer. 5.16. What is the ratio of the Cost of communications, computer etc. (% of service imports) in European Union in 2006 to that in 2007?
Provide a short and direct response. 0.97. What is the ratio of the Cost of communications, computer etc. (% of service imports) in Colombia in 2006 to that in 2007?
Provide a succinct answer. 1.01. What is the ratio of the Cost of communications, computer etc. (% of service imports) in Myanmar in 2006 to that in 2007?
Ensure brevity in your answer.  1.01. What is the ratio of the Cost of communications, computer etc. (% of service imports) of European Union in 2006 to that in 2008?
Make the answer very short. 0.96. What is the ratio of the Cost of communications, computer etc. (% of service imports) of Colombia in 2006 to that in 2008?
Make the answer very short. 0.99. What is the ratio of the Cost of communications, computer etc. (% of service imports) of Myanmar in 2006 to that in 2008?
Give a very brief answer. 2.66. What is the ratio of the Cost of communications, computer etc. (% of service imports) of European Union in 2006 to that in 2009?
Offer a terse response. 0.9. What is the ratio of the Cost of communications, computer etc. (% of service imports) of Colombia in 2006 to that in 2009?
Keep it short and to the point. 0.78. What is the ratio of the Cost of communications, computer etc. (% of service imports) of Myanmar in 2006 to that in 2009?
Offer a very short reply. 2.8. What is the ratio of the Cost of communications, computer etc. (% of service imports) in European Union in 2006 to that in 2010?
Provide a short and direct response. 0.92. What is the ratio of the Cost of communications, computer etc. (% of service imports) of Colombia in 2006 to that in 2010?
Offer a terse response. 0.81. What is the ratio of the Cost of communications, computer etc. (% of service imports) of Myanmar in 2006 to that in 2010?
Offer a terse response. 1.33. What is the ratio of the Cost of communications, computer etc. (% of service imports) in European Union in 2006 to that in 2011?
Keep it short and to the point. 0.91. What is the ratio of the Cost of communications, computer etc. (% of service imports) in Colombia in 2006 to that in 2011?
Keep it short and to the point. 0.77. What is the ratio of the Cost of communications, computer etc. (% of service imports) of Myanmar in 2006 to that in 2011?
Make the answer very short. 2.44. What is the ratio of the Cost of communications, computer etc. (% of service imports) in European Union in 2006 to that in 2012?
Give a very brief answer. 0.89. What is the ratio of the Cost of communications, computer etc. (% of service imports) of Colombia in 2006 to that in 2012?
Ensure brevity in your answer.  0.82. What is the ratio of the Cost of communications, computer etc. (% of service imports) in Myanmar in 2006 to that in 2012?
Provide a short and direct response. 1.66. What is the ratio of the Cost of communications, computer etc. (% of service imports) of European Union in 2006 to that in 2013?
Your response must be concise. 0.89. What is the ratio of the Cost of communications, computer etc. (% of service imports) of Colombia in 2006 to that in 2013?
Give a very brief answer. 0.73. What is the ratio of the Cost of communications, computer etc. (% of service imports) of Myanmar in 2006 to that in 2013?
Your answer should be compact. 1.79. What is the ratio of the Cost of communications, computer etc. (% of service imports) of European Union in 2007 to that in 2008?
Offer a terse response. 0.99. What is the ratio of the Cost of communications, computer etc. (% of service imports) in Colombia in 2007 to that in 2008?
Your answer should be compact. 0.97. What is the ratio of the Cost of communications, computer etc. (% of service imports) of Myanmar in 2007 to that in 2008?
Provide a short and direct response. 2.62. What is the ratio of the Cost of communications, computer etc. (% of service imports) of European Union in 2007 to that in 2009?
Provide a short and direct response. 0.93. What is the ratio of the Cost of communications, computer etc. (% of service imports) in Colombia in 2007 to that in 2009?
Offer a very short reply. 0.77. What is the ratio of the Cost of communications, computer etc. (% of service imports) of Myanmar in 2007 to that in 2009?
Offer a terse response. 2.76. What is the ratio of the Cost of communications, computer etc. (% of service imports) in European Union in 2007 to that in 2010?
Offer a terse response. 0.95. What is the ratio of the Cost of communications, computer etc. (% of service imports) of Colombia in 2007 to that in 2010?
Keep it short and to the point. 0.79. What is the ratio of the Cost of communications, computer etc. (% of service imports) in Myanmar in 2007 to that in 2010?
Provide a short and direct response. 1.31. What is the ratio of the Cost of communications, computer etc. (% of service imports) in European Union in 2007 to that in 2011?
Make the answer very short. 0.94. What is the ratio of the Cost of communications, computer etc. (% of service imports) of Colombia in 2007 to that in 2011?
Ensure brevity in your answer.  0.76. What is the ratio of the Cost of communications, computer etc. (% of service imports) of Myanmar in 2007 to that in 2011?
Make the answer very short. 2.4. What is the ratio of the Cost of communications, computer etc. (% of service imports) in European Union in 2007 to that in 2012?
Give a very brief answer. 0.92. What is the ratio of the Cost of communications, computer etc. (% of service imports) of Colombia in 2007 to that in 2012?
Your answer should be compact. 0.81. What is the ratio of the Cost of communications, computer etc. (% of service imports) in Myanmar in 2007 to that in 2012?
Ensure brevity in your answer.  1.64. What is the ratio of the Cost of communications, computer etc. (% of service imports) of European Union in 2007 to that in 2013?
Your answer should be very brief. 0.92. What is the ratio of the Cost of communications, computer etc. (% of service imports) of Colombia in 2007 to that in 2013?
Provide a succinct answer. 0.72. What is the ratio of the Cost of communications, computer etc. (% of service imports) in Myanmar in 2007 to that in 2013?
Offer a terse response. 1.76. What is the ratio of the Cost of communications, computer etc. (% of service imports) in European Union in 2008 to that in 2009?
Your response must be concise. 0.94. What is the ratio of the Cost of communications, computer etc. (% of service imports) in Colombia in 2008 to that in 2009?
Provide a succinct answer. 0.79. What is the ratio of the Cost of communications, computer etc. (% of service imports) of Myanmar in 2008 to that in 2009?
Your answer should be compact. 1.05. What is the ratio of the Cost of communications, computer etc. (% of service imports) of European Union in 2008 to that in 2010?
Your answer should be compact. 0.96. What is the ratio of the Cost of communications, computer etc. (% of service imports) in Colombia in 2008 to that in 2010?
Provide a short and direct response. 0.82. What is the ratio of the Cost of communications, computer etc. (% of service imports) of Myanmar in 2008 to that in 2010?
Provide a short and direct response. 0.5. What is the ratio of the Cost of communications, computer etc. (% of service imports) of European Union in 2008 to that in 2011?
Your response must be concise. 0.95. What is the ratio of the Cost of communications, computer etc. (% of service imports) in Colombia in 2008 to that in 2011?
Provide a short and direct response. 0.78. What is the ratio of the Cost of communications, computer etc. (% of service imports) of Myanmar in 2008 to that in 2011?
Your answer should be compact. 0.92. What is the ratio of the Cost of communications, computer etc. (% of service imports) in European Union in 2008 to that in 2012?
Your answer should be very brief. 0.92. What is the ratio of the Cost of communications, computer etc. (% of service imports) of Colombia in 2008 to that in 2012?
Ensure brevity in your answer.  0.83. What is the ratio of the Cost of communications, computer etc. (% of service imports) of Myanmar in 2008 to that in 2012?
Make the answer very short. 0.63. What is the ratio of the Cost of communications, computer etc. (% of service imports) of European Union in 2008 to that in 2013?
Give a very brief answer. 0.92. What is the ratio of the Cost of communications, computer etc. (% of service imports) of Colombia in 2008 to that in 2013?
Ensure brevity in your answer.  0.74. What is the ratio of the Cost of communications, computer etc. (% of service imports) in Myanmar in 2008 to that in 2013?
Keep it short and to the point. 0.67. What is the ratio of the Cost of communications, computer etc. (% of service imports) in European Union in 2009 to that in 2010?
Offer a terse response. 1.02. What is the ratio of the Cost of communications, computer etc. (% of service imports) in Colombia in 2009 to that in 2010?
Your answer should be very brief. 1.03. What is the ratio of the Cost of communications, computer etc. (% of service imports) of Myanmar in 2009 to that in 2010?
Provide a short and direct response. 0.47. What is the ratio of the Cost of communications, computer etc. (% of service imports) in European Union in 2009 to that in 2011?
Provide a succinct answer. 1.01. What is the ratio of the Cost of communications, computer etc. (% of service imports) of Colombia in 2009 to that in 2011?
Ensure brevity in your answer.  0.98. What is the ratio of the Cost of communications, computer etc. (% of service imports) in Myanmar in 2009 to that in 2011?
Provide a short and direct response. 0.87. What is the ratio of the Cost of communications, computer etc. (% of service imports) of European Union in 2009 to that in 2012?
Give a very brief answer. 0.98. What is the ratio of the Cost of communications, computer etc. (% of service imports) in Colombia in 2009 to that in 2012?
Offer a very short reply. 1.05. What is the ratio of the Cost of communications, computer etc. (% of service imports) of Myanmar in 2009 to that in 2012?
Ensure brevity in your answer.  0.59. What is the ratio of the Cost of communications, computer etc. (% of service imports) of European Union in 2009 to that in 2013?
Make the answer very short. 0.98. What is the ratio of the Cost of communications, computer etc. (% of service imports) in Colombia in 2009 to that in 2013?
Ensure brevity in your answer.  0.93. What is the ratio of the Cost of communications, computer etc. (% of service imports) of Myanmar in 2009 to that in 2013?
Offer a terse response. 0.64. What is the ratio of the Cost of communications, computer etc. (% of service imports) in European Union in 2010 to that in 2011?
Offer a terse response. 0.99. What is the ratio of the Cost of communications, computer etc. (% of service imports) of Colombia in 2010 to that in 2011?
Give a very brief answer. 0.95. What is the ratio of the Cost of communications, computer etc. (% of service imports) in Myanmar in 2010 to that in 2011?
Your answer should be very brief. 1.83. What is the ratio of the Cost of communications, computer etc. (% of service imports) of European Union in 2010 to that in 2012?
Your answer should be very brief. 0.96. What is the ratio of the Cost of communications, computer etc. (% of service imports) of Colombia in 2010 to that in 2012?
Your answer should be compact. 1.02. What is the ratio of the Cost of communications, computer etc. (% of service imports) in Myanmar in 2010 to that in 2012?
Offer a terse response. 1.25. What is the ratio of the Cost of communications, computer etc. (% of service imports) in European Union in 2010 to that in 2013?
Your answer should be compact. 0.96. What is the ratio of the Cost of communications, computer etc. (% of service imports) of Colombia in 2010 to that in 2013?
Offer a very short reply. 0.91. What is the ratio of the Cost of communications, computer etc. (% of service imports) of Myanmar in 2010 to that in 2013?
Offer a terse response. 1.34. What is the ratio of the Cost of communications, computer etc. (% of service imports) of Colombia in 2011 to that in 2012?
Your answer should be compact. 1.07. What is the ratio of the Cost of communications, computer etc. (% of service imports) in Myanmar in 2011 to that in 2012?
Make the answer very short. 0.68. What is the ratio of the Cost of communications, computer etc. (% of service imports) of European Union in 2011 to that in 2013?
Make the answer very short. 0.97. What is the ratio of the Cost of communications, computer etc. (% of service imports) in Colombia in 2011 to that in 2013?
Make the answer very short. 0.95. What is the ratio of the Cost of communications, computer etc. (% of service imports) of Myanmar in 2011 to that in 2013?
Provide a succinct answer. 0.73. What is the ratio of the Cost of communications, computer etc. (% of service imports) of Colombia in 2012 to that in 2013?
Ensure brevity in your answer.  0.89. What is the ratio of the Cost of communications, computer etc. (% of service imports) in Myanmar in 2012 to that in 2013?
Keep it short and to the point. 1.07. What is the difference between the highest and the second highest Cost of communications, computer etc. (% of service imports) in European Union?
Keep it short and to the point. 0.18. What is the difference between the highest and the second highest Cost of communications, computer etc. (% of service imports) in Colombia?
Provide a short and direct response. 1.65. What is the difference between the highest and the second highest Cost of communications, computer etc. (% of service imports) of Myanmar?
Provide a succinct answer. 0.65. What is the difference between the highest and the lowest Cost of communications, computer etc. (% of service imports) of European Union?
Your response must be concise. 5.8. What is the difference between the highest and the lowest Cost of communications, computer etc. (% of service imports) in Colombia?
Your answer should be very brief. 9.02. What is the difference between the highest and the lowest Cost of communications, computer etc. (% of service imports) of Myanmar?
Your answer should be very brief. 31.02. 